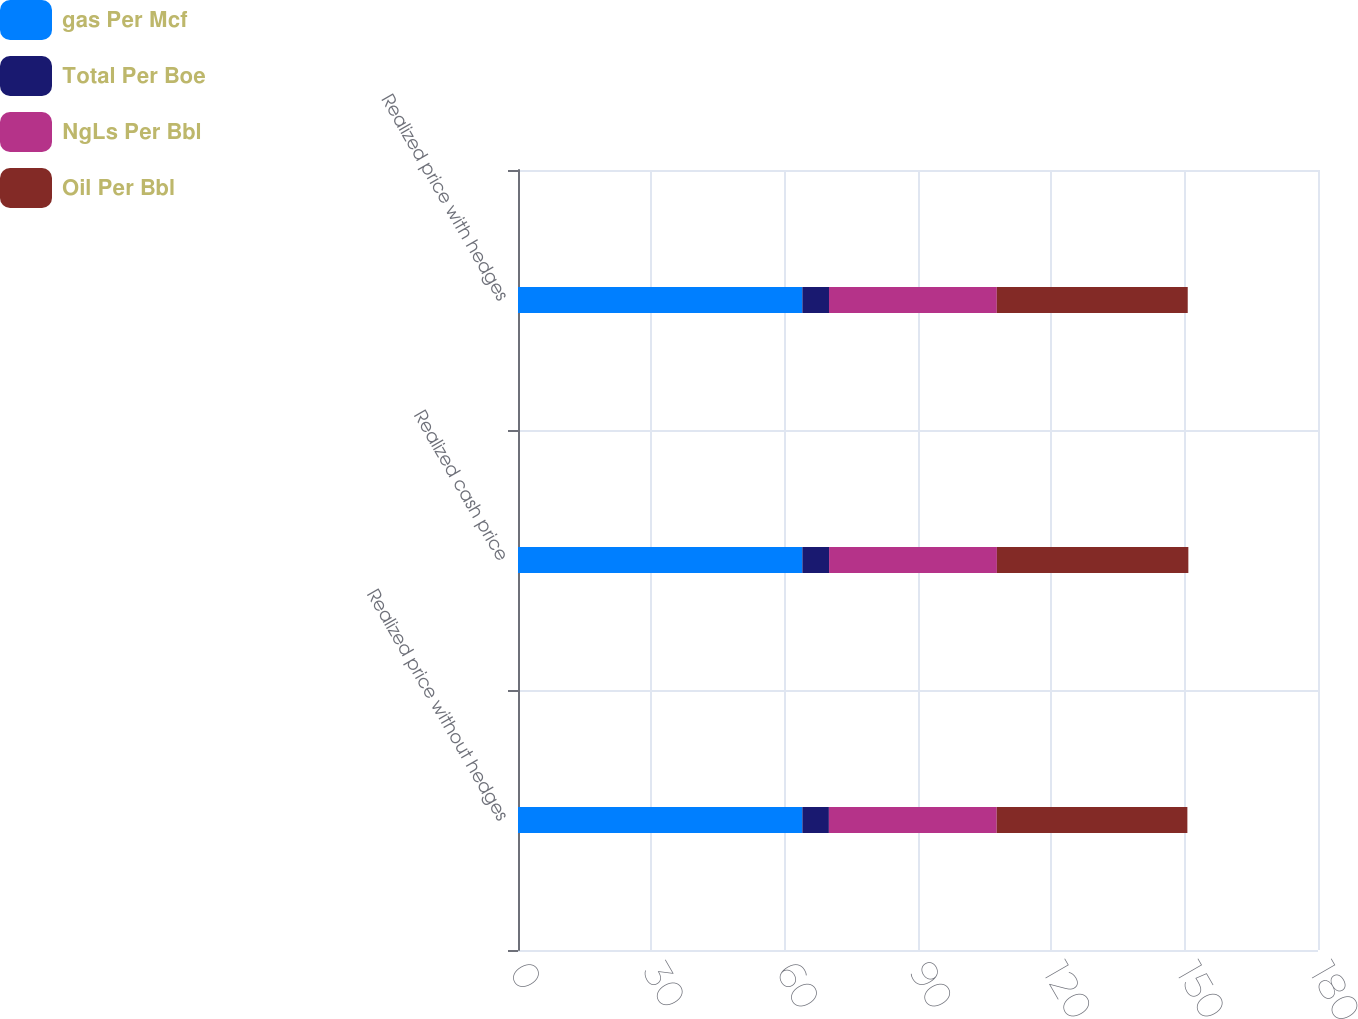Convert chart to OTSL. <chart><loc_0><loc_0><loc_500><loc_500><stacked_bar_chart><ecel><fcel>Realized price without hedges<fcel>Realized cash price<fcel>Realized price with hedges<nl><fcel>gas Per Mcf<fcel>63.98<fcel>63.98<fcel>63.98<nl><fcel>Total Per Boe<fcel>5.97<fcel>6.01<fcel>5.99<nl><fcel>NgLs Per Bbl<fcel>37.76<fcel>37.76<fcel>37.76<nl><fcel>Oil Per Bbl<fcel>42.9<fcel>43.08<fcel>42.96<nl></chart> 